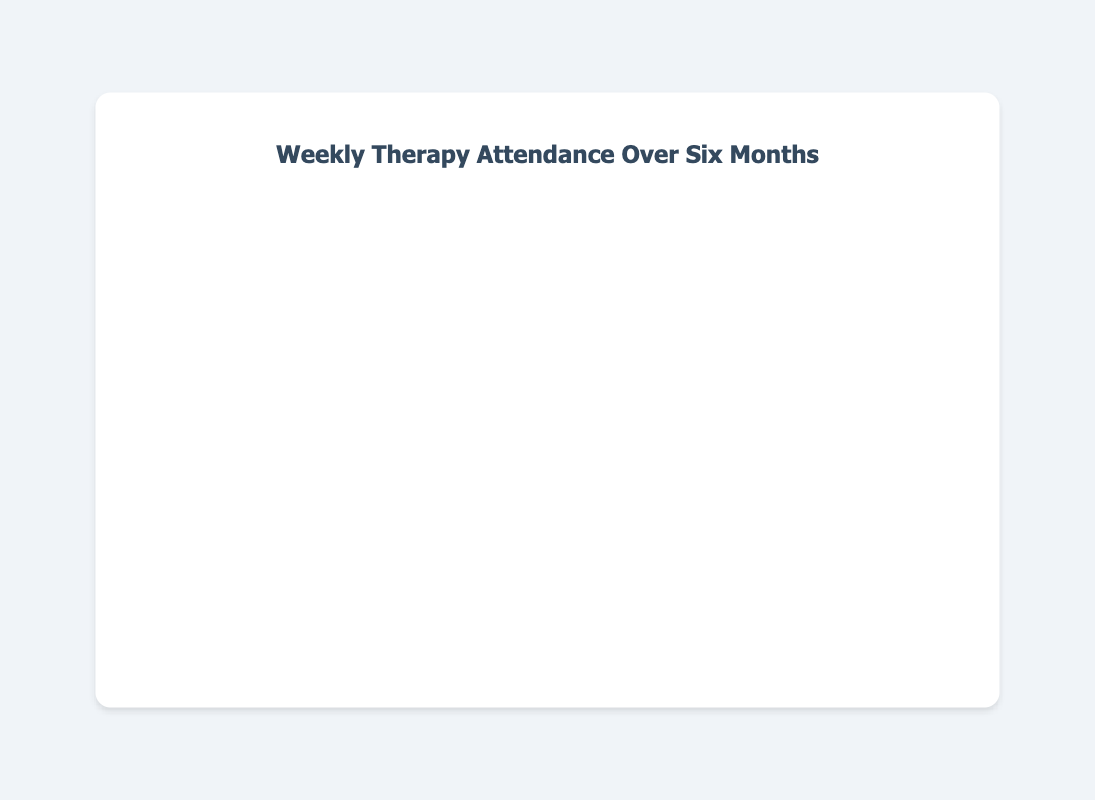What is the highest number of attended sessions in any week? The highest number of attended sessions can be identified by looking for the peak point on the line chart. The peak point corresponds to 4 attended sessions, which occurred multiple times.
Answer: 4 During which week(s) did the lowest number of attended sessions occur? Find the lowest point on the line chart, which represents the week(s) with the minimum number of attended sessions. It occurs on 2023-01-15, 2023-03-12, 2023-04-30, and 2023-06-11, each with 1 session.
Answer: 2023-01-15, 2023-03-12, 2023-04-30, 2023-06-11 What is the average number of attended sessions per week over the six-month period? Calculate the average by summing all the attended sessions and dividing by the number of weeks. Sum is 66, and the number of weeks is 26. So, the average is 66/26 = 2.54.
Answer: 2.54 How many weeks had exactly 3 attended sessions? Count the weeks where the number of attended sessions equals 3. These weeks are 2023-01-08, 2023-01-29, 2023-02-19, 2023-03-05, 2023-03-19, 2023-04-09, 2023-04-23, 2023-05-14, 2023-06-04, and 2023-06-25.
Answer: 10 During which month(s) did the number of attended sessions peak the most frequently? Identify the month(s) where the peak value of 4 sessions is seen most often. Peak values of 4 are on 2023-02-12, 2023-04-02, and 2023-05-21, which occurs most in February, April, May.
Answer: February, April, May Which week shows a sudden increase in the number of attended sessions compared to the previous week? Look for significant upward spikes on the line chart. One such week is 2023-02-12, where sessions jumped from 2 to 4 compared to the previous week.
Answer: 2023-02-12 What is the total number of attended sessions in April? Add the sessions for all weeks in April. Sessions are 4 (2023-04-02), 3 (2023-04-09), 2 (2023-04-16), 3 (2023-04-23), and 1 (2023-04-30), totaling 4 + 3 + 2 + 3 + 1 = 13.
Answer: 13 In which week(s) does the line chart display a flat or non-changing number of attended sessions compared to the previous week? Look for horizontal segments on the line chart. For instance, the weeks 2023-03-19 and 2023-02-19 both maintain 3 sessions from their respective previous weeks.
Answer: 2023-03-19 and 2023-02-19 What is the difference between the maximum and minimum number of attended sessions in a week? Subtract the minimum value of attended sessions (1) from the maximum (4), resulting in 4 - 1 = 3.
Answer: 3 